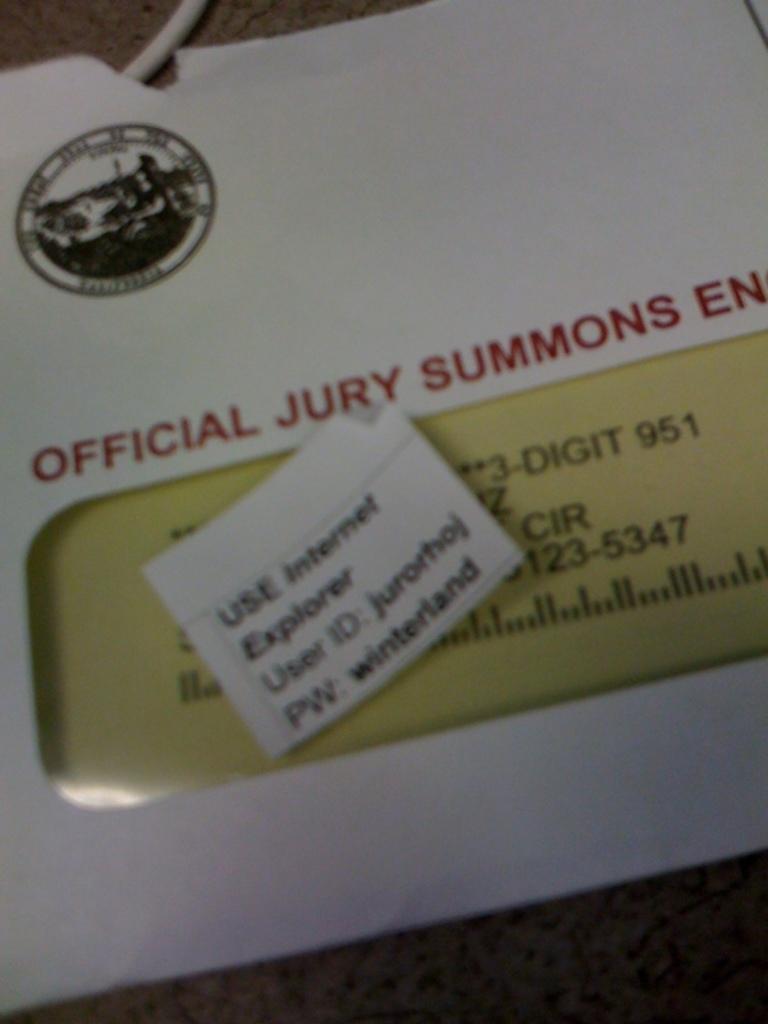What type of summons is this?
Keep it short and to the point. Jury. This is what kind of official letter?
Provide a succinct answer. Jury summons. 